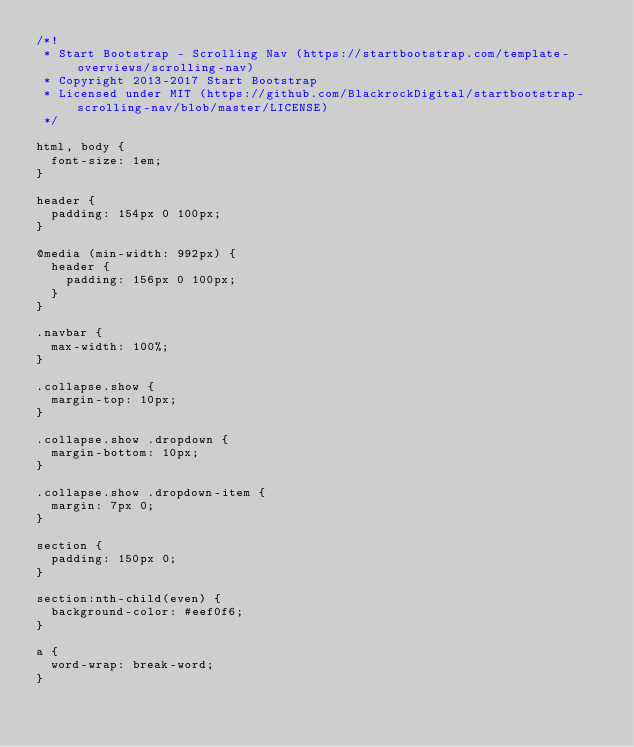Convert code to text. <code><loc_0><loc_0><loc_500><loc_500><_CSS_>/*!
 * Start Bootstrap - Scrolling Nav (https://startbootstrap.com/template-overviews/scrolling-nav)
 * Copyright 2013-2017 Start Bootstrap
 * Licensed under MIT (https://github.com/BlackrockDigital/startbootstrap-scrolling-nav/blob/master/LICENSE)
 */

html, body {
  font-size: 1em;
}

header {
  padding: 154px 0 100px;
}

@media (min-width: 992px) {
  header {
    padding: 156px 0 100px;
  }
}

.navbar {  
  max-width: 100%;
}

.collapse.show {
  margin-top: 10px;
}

.collapse.show .dropdown {
  margin-bottom: 10px;
}

.collapse.show .dropdown-item {
  margin: 7px 0;
}

section {
  padding: 150px 0;
}

section:nth-child(even) {
  background-color: #eef0f6;
}

a {
  word-wrap: break-word;
}</code> 